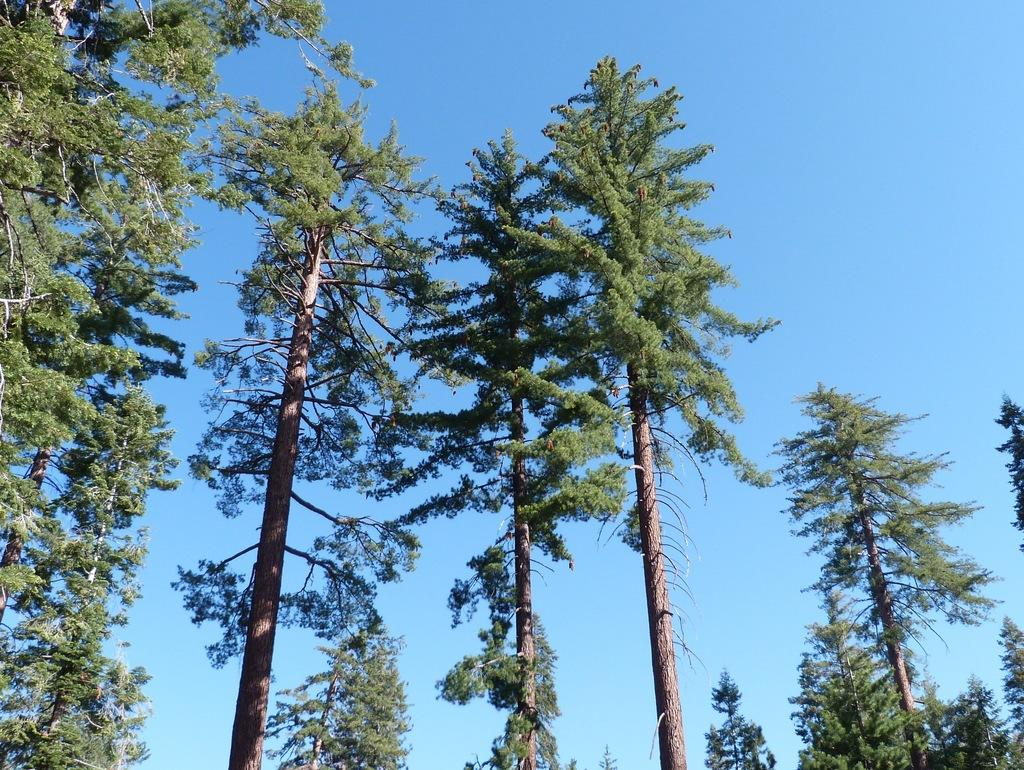What type of vegetation can be seen in the image? There are trees in the image. What part of the natural environment is visible in the image? The sky is visible in the background of the image. What type of list is on the desk in the image? There is no desk or list present in the image; it only features trees and the sky. 